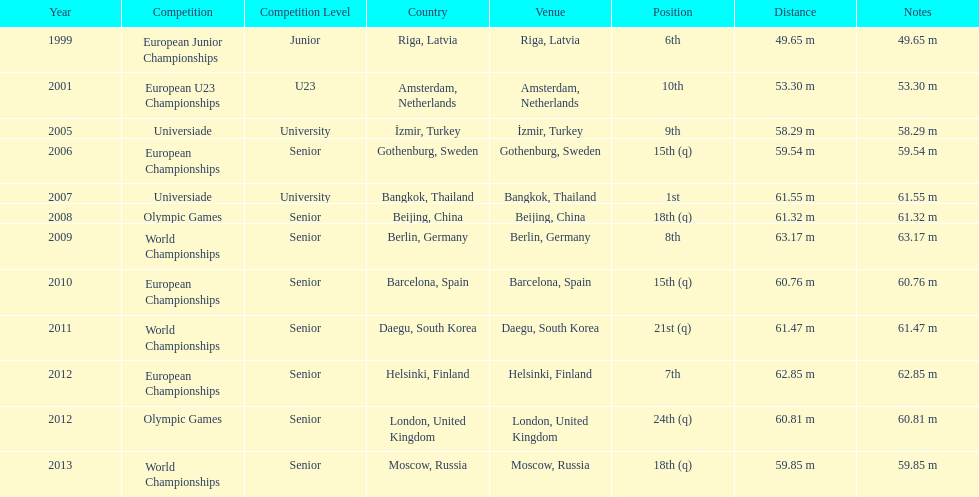What was mayer's best result: i.e his longest throw? 63.17 m. 